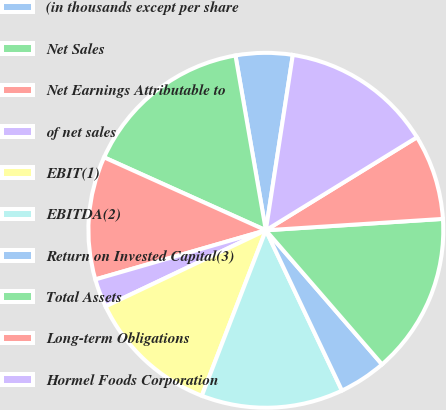Convert chart to OTSL. <chart><loc_0><loc_0><loc_500><loc_500><pie_chart><fcel>(in thousands except per share<fcel>Net Sales<fcel>Net Earnings Attributable to<fcel>of net sales<fcel>EBIT(1)<fcel>EBITDA(2)<fcel>Return on Invested Capital(3)<fcel>Total Assets<fcel>Long-term Obligations<fcel>Hormel Foods Corporation<nl><fcel>5.17%<fcel>15.52%<fcel>11.21%<fcel>2.59%<fcel>12.07%<fcel>12.93%<fcel>4.31%<fcel>14.66%<fcel>7.76%<fcel>13.79%<nl></chart> 